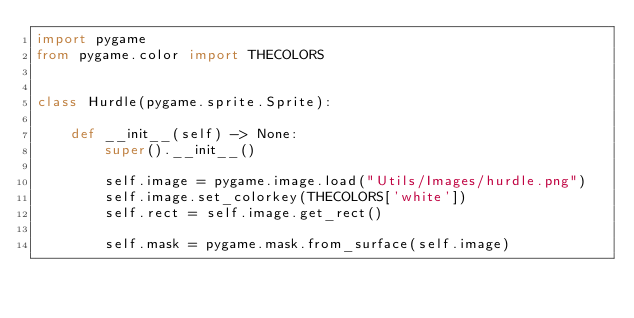<code> <loc_0><loc_0><loc_500><loc_500><_Python_>import pygame
from pygame.color import THECOLORS


class Hurdle(pygame.sprite.Sprite):

    def __init__(self) -> None:
        super().__init__()

        self.image = pygame.image.load("Utils/Images/hurdle.png")
        self.image.set_colorkey(THECOLORS['white'])
        self.rect = self.image.get_rect()

        self.mask = pygame.mask.from_surface(self.image)</code> 